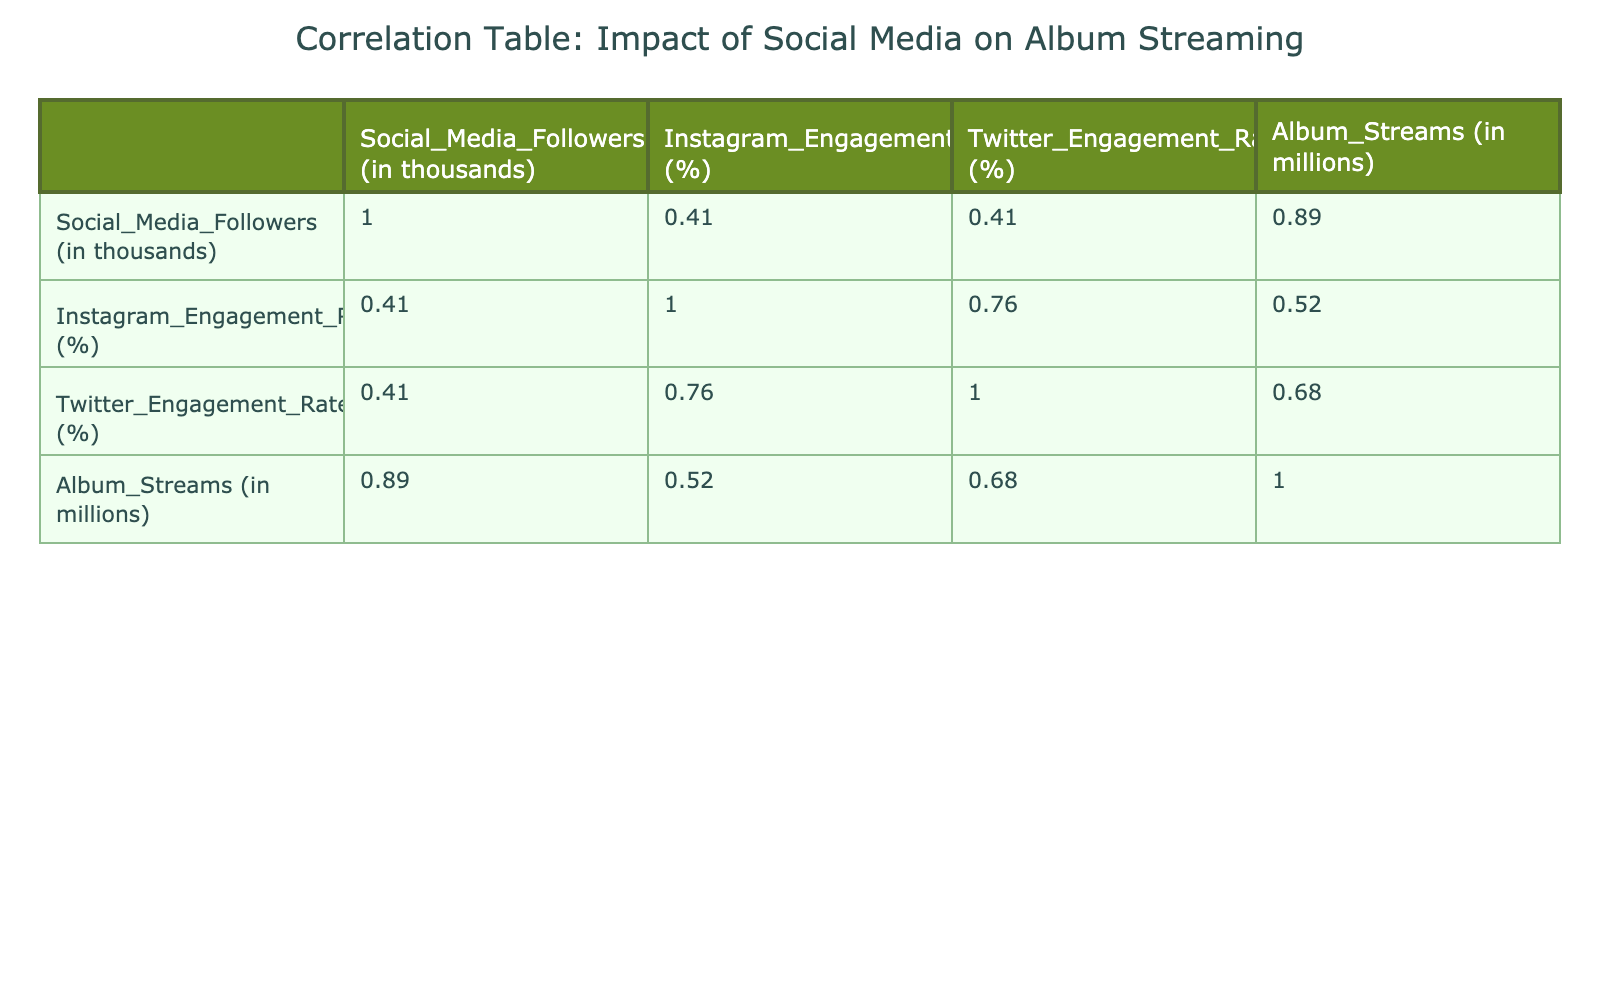What is the correlation between Social Media Followers and Album Streams? To find this correlation, we look at the correlation coefficient from the table. The value for Social Media Followers and Album Streams is 0.90, indicating a strong positive correlation.
Answer: 0.90 Which artist has the highest Instagram Engagement Rate, and what is that rate? By inspecting the table, we identify that Beyoncé has the highest Instagram Engagement Rate of 4.1%.
Answer: Beyoncé, 4.1% Is it true that Ariana Grande has more Album Streams than Aretha Franklin? We compare the Album Streams values for both artists in the table. Ariana Grande has 30.0 million streams, while Aretha Franklin has 5.0 million streams, confirming that Ariana Grande indeed has more Album Streams.
Answer: Yes What is the average Album Streams for artists with more than 250,000 Social Media Followers? We identify the artists with more than 250,000 followers: Ariana Grande (30.0), Beyoncé (45.0), Taylor Swift (60.0), and Ed Sheeran (55.0). Summing these amounts gives 30.0 + 45.0 + 60.0 + 55.0 = 190.0 million streams. There are 4 artists, so the average is 190.0 / 4 = 47.5 million streams.
Answer: 47.5 million Which artist has a lower Twitter Engagement Rate than Aretha Franklin? Checking the Twitter Engagement Rates, we see that Aretha Franklin has a rate of 1.2%. Looking through the table, both Bruno Mars (1.8%) and Dua Lipa (2.1%) have higher rates, meaning no artist has a lower rate than her.
Answer: No artist has a lower rate 